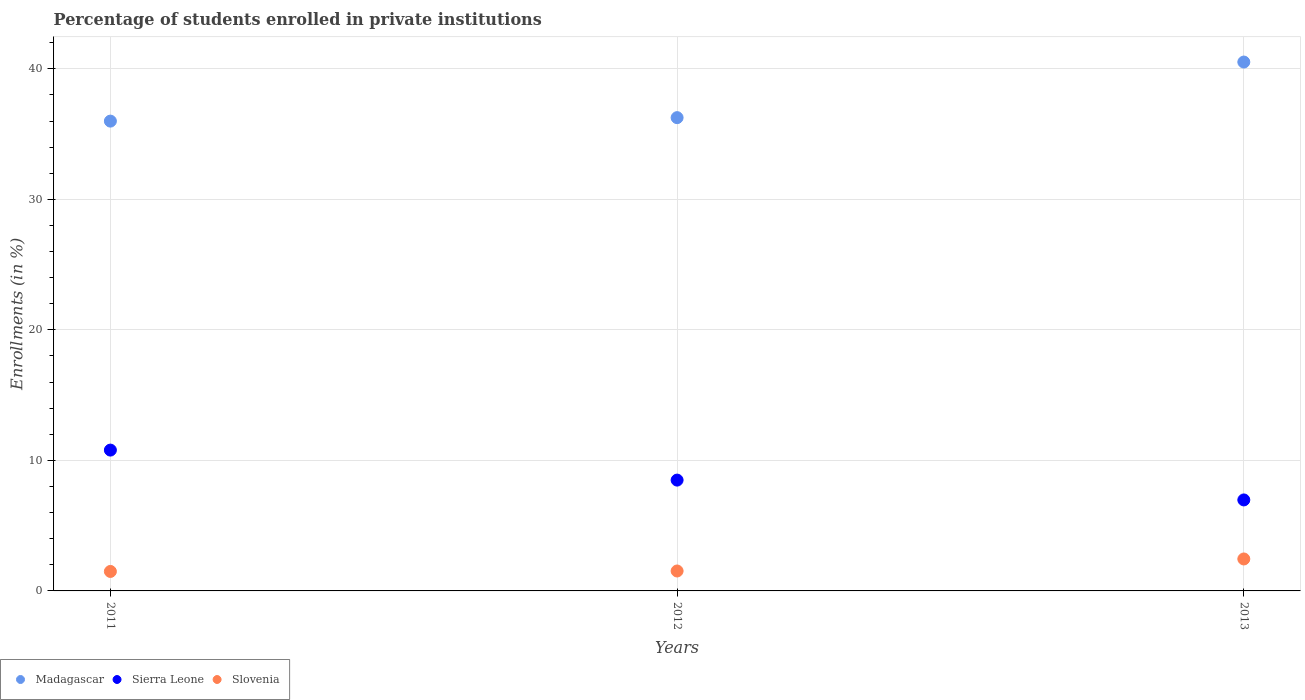What is the percentage of trained teachers in Sierra Leone in 2012?
Ensure brevity in your answer.  8.49. Across all years, what is the maximum percentage of trained teachers in Madagascar?
Offer a terse response. 40.52. Across all years, what is the minimum percentage of trained teachers in Slovenia?
Your response must be concise. 1.49. In which year was the percentage of trained teachers in Madagascar minimum?
Keep it short and to the point. 2011. What is the total percentage of trained teachers in Madagascar in the graph?
Offer a very short reply. 112.78. What is the difference between the percentage of trained teachers in Madagascar in 2011 and that in 2013?
Provide a succinct answer. -4.53. What is the difference between the percentage of trained teachers in Slovenia in 2011 and the percentage of trained teachers in Sierra Leone in 2012?
Offer a very short reply. -7. What is the average percentage of trained teachers in Sierra Leone per year?
Make the answer very short. 8.75. In the year 2012, what is the difference between the percentage of trained teachers in Slovenia and percentage of trained teachers in Madagascar?
Your response must be concise. -34.73. What is the ratio of the percentage of trained teachers in Slovenia in 2011 to that in 2012?
Offer a terse response. 0.98. Is the percentage of trained teachers in Madagascar in 2012 less than that in 2013?
Keep it short and to the point. Yes. Is the difference between the percentage of trained teachers in Slovenia in 2011 and 2013 greater than the difference between the percentage of trained teachers in Madagascar in 2011 and 2013?
Offer a very short reply. Yes. What is the difference between the highest and the second highest percentage of trained teachers in Sierra Leone?
Offer a terse response. 2.3. What is the difference between the highest and the lowest percentage of trained teachers in Slovenia?
Offer a terse response. 0.96. In how many years, is the percentage of trained teachers in Sierra Leone greater than the average percentage of trained teachers in Sierra Leone taken over all years?
Make the answer very short. 1. Is the sum of the percentage of trained teachers in Slovenia in 2012 and 2013 greater than the maximum percentage of trained teachers in Madagascar across all years?
Your answer should be very brief. No. Does the percentage of trained teachers in Sierra Leone monotonically increase over the years?
Your response must be concise. No. What is the difference between two consecutive major ticks on the Y-axis?
Offer a very short reply. 10. Does the graph contain grids?
Ensure brevity in your answer.  Yes. Where does the legend appear in the graph?
Your answer should be compact. Bottom left. What is the title of the graph?
Ensure brevity in your answer.  Percentage of students enrolled in private institutions. Does "Chad" appear as one of the legend labels in the graph?
Make the answer very short. No. What is the label or title of the X-axis?
Provide a short and direct response. Years. What is the label or title of the Y-axis?
Provide a short and direct response. Enrollments (in %). What is the Enrollments (in %) in Madagascar in 2011?
Give a very brief answer. 36. What is the Enrollments (in %) of Sierra Leone in 2011?
Your answer should be compact. 10.79. What is the Enrollments (in %) of Slovenia in 2011?
Your answer should be compact. 1.49. What is the Enrollments (in %) in Madagascar in 2012?
Your answer should be compact. 36.26. What is the Enrollments (in %) in Sierra Leone in 2012?
Provide a succinct answer. 8.49. What is the Enrollments (in %) in Slovenia in 2012?
Provide a short and direct response. 1.53. What is the Enrollments (in %) in Madagascar in 2013?
Your answer should be very brief. 40.52. What is the Enrollments (in %) of Sierra Leone in 2013?
Ensure brevity in your answer.  6.97. What is the Enrollments (in %) in Slovenia in 2013?
Provide a succinct answer. 2.45. Across all years, what is the maximum Enrollments (in %) in Madagascar?
Your response must be concise. 40.52. Across all years, what is the maximum Enrollments (in %) in Sierra Leone?
Your answer should be very brief. 10.79. Across all years, what is the maximum Enrollments (in %) in Slovenia?
Your answer should be compact. 2.45. Across all years, what is the minimum Enrollments (in %) in Madagascar?
Provide a succinct answer. 36. Across all years, what is the minimum Enrollments (in %) in Sierra Leone?
Your answer should be compact. 6.97. Across all years, what is the minimum Enrollments (in %) of Slovenia?
Ensure brevity in your answer.  1.49. What is the total Enrollments (in %) of Madagascar in the graph?
Offer a very short reply. 112.78. What is the total Enrollments (in %) of Sierra Leone in the graph?
Ensure brevity in your answer.  26.25. What is the total Enrollments (in %) in Slovenia in the graph?
Ensure brevity in your answer.  5.47. What is the difference between the Enrollments (in %) of Madagascar in 2011 and that in 2012?
Provide a succinct answer. -0.27. What is the difference between the Enrollments (in %) of Sierra Leone in 2011 and that in 2012?
Your response must be concise. 2.3. What is the difference between the Enrollments (in %) of Slovenia in 2011 and that in 2012?
Make the answer very short. -0.04. What is the difference between the Enrollments (in %) in Madagascar in 2011 and that in 2013?
Offer a terse response. -4.53. What is the difference between the Enrollments (in %) of Sierra Leone in 2011 and that in 2013?
Ensure brevity in your answer.  3.82. What is the difference between the Enrollments (in %) of Slovenia in 2011 and that in 2013?
Offer a very short reply. -0.96. What is the difference between the Enrollments (in %) of Madagascar in 2012 and that in 2013?
Make the answer very short. -4.26. What is the difference between the Enrollments (in %) of Sierra Leone in 2012 and that in 2013?
Your answer should be very brief. 1.52. What is the difference between the Enrollments (in %) of Slovenia in 2012 and that in 2013?
Provide a succinct answer. -0.92. What is the difference between the Enrollments (in %) in Madagascar in 2011 and the Enrollments (in %) in Sierra Leone in 2012?
Your answer should be compact. 27.5. What is the difference between the Enrollments (in %) of Madagascar in 2011 and the Enrollments (in %) of Slovenia in 2012?
Make the answer very short. 34.47. What is the difference between the Enrollments (in %) of Sierra Leone in 2011 and the Enrollments (in %) of Slovenia in 2012?
Your response must be concise. 9.26. What is the difference between the Enrollments (in %) of Madagascar in 2011 and the Enrollments (in %) of Sierra Leone in 2013?
Your answer should be very brief. 29.02. What is the difference between the Enrollments (in %) of Madagascar in 2011 and the Enrollments (in %) of Slovenia in 2013?
Keep it short and to the point. 33.55. What is the difference between the Enrollments (in %) of Sierra Leone in 2011 and the Enrollments (in %) of Slovenia in 2013?
Give a very brief answer. 8.34. What is the difference between the Enrollments (in %) in Madagascar in 2012 and the Enrollments (in %) in Sierra Leone in 2013?
Keep it short and to the point. 29.29. What is the difference between the Enrollments (in %) of Madagascar in 2012 and the Enrollments (in %) of Slovenia in 2013?
Provide a short and direct response. 33.81. What is the difference between the Enrollments (in %) in Sierra Leone in 2012 and the Enrollments (in %) in Slovenia in 2013?
Ensure brevity in your answer.  6.04. What is the average Enrollments (in %) in Madagascar per year?
Your answer should be very brief. 37.59. What is the average Enrollments (in %) of Sierra Leone per year?
Ensure brevity in your answer.  8.75. What is the average Enrollments (in %) in Slovenia per year?
Your response must be concise. 1.82. In the year 2011, what is the difference between the Enrollments (in %) in Madagascar and Enrollments (in %) in Sierra Leone?
Ensure brevity in your answer.  25.21. In the year 2011, what is the difference between the Enrollments (in %) of Madagascar and Enrollments (in %) of Slovenia?
Your answer should be compact. 34.5. In the year 2011, what is the difference between the Enrollments (in %) in Sierra Leone and Enrollments (in %) in Slovenia?
Your response must be concise. 9.3. In the year 2012, what is the difference between the Enrollments (in %) in Madagascar and Enrollments (in %) in Sierra Leone?
Your answer should be very brief. 27.77. In the year 2012, what is the difference between the Enrollments (in %) of Madagascar and Enrollments (in %) of Slovenia?
Provide a succinct answer. 34.73. In the year 2012, what is the difference between the Enrollments (in %) in Sierra Leone and Enrollments (in %) in Slovenia?
Offer a terse response. 6.96. In the year 2013, what is the difference between the Enrollments (in %) of Madagascar and Enrollments (in %) of Sierra Leone?
Make the answer very short. 33.55. In the year 2013, what is the difference between the Enrollments (in %) of Madagascar and Enrollments (in %) of Slovenia?
Provide a succinct answer. 38.07. In the year 2013, what is the difference between the Enrollments (in %) in Sierra Leone and Enrollments (in %) in Slovenia?
Ensure brevity in your answer.  4.52. What is the ratio of the Enrollments (in %) of Sierra Leone in 2011 to that in 2012?
Provide a short and direct response. 1.27. What is the ratio of the Enrollments (in %) in Slovenia in 2011 to that in 2012?
Offer a very short reply. 0.98. What is the ratio of the Enrollments (in %) of Madagascar in 2011 to that in 2013?
Offer a terse response. 0.89. What is the ratio of the Enrollments (in %) of Sierra Leone in 2011 to that in 2013?
Give a very brief answer. 1.55. What is the ratio of the Enrollments (in %) of Slovenia in 2011 to that in 2013?
Your answer should be very brief. 0.61. What is the ratio of the Enrollments (in %) of Madagascar in 2012 to that in 2013?
Provide a succinct answer. 0.89. What is the ratio of the Enrollments (in %) in Sierra Leone in 2012 to that in 2013?
Keep it short and to the point. 1.22. What is the ratio of the Enrollments (in %) of Slovenia in 2012 to that in 2013?
Offer a very short reply. 0.62. What is the difference between the highest and the second highest Enrollments (in %) of Madagascar?
Provide a short and direct response. 4.26. What is the difference between the highest and the second highest Enrollments (in %) in Sierra Leone?
Offer a terse response. 2.3. What is the difference between the highest and the second highest Enrollments (in %) in Slovenia?
Your answer should be very brief. 0.92. What is the difference between the highest and the lowest Enrollments (in %) of Madagascar?
Make the answer very short. 4.53. What is the difference between the highest and the lowest Enrollments (in %) of Sierra Leone?
Your response must be concise. 3.82. What is the difference between the highest and the lowest Enrollments (in %) of Slovenia?
Make the answer very short. 0.96. 